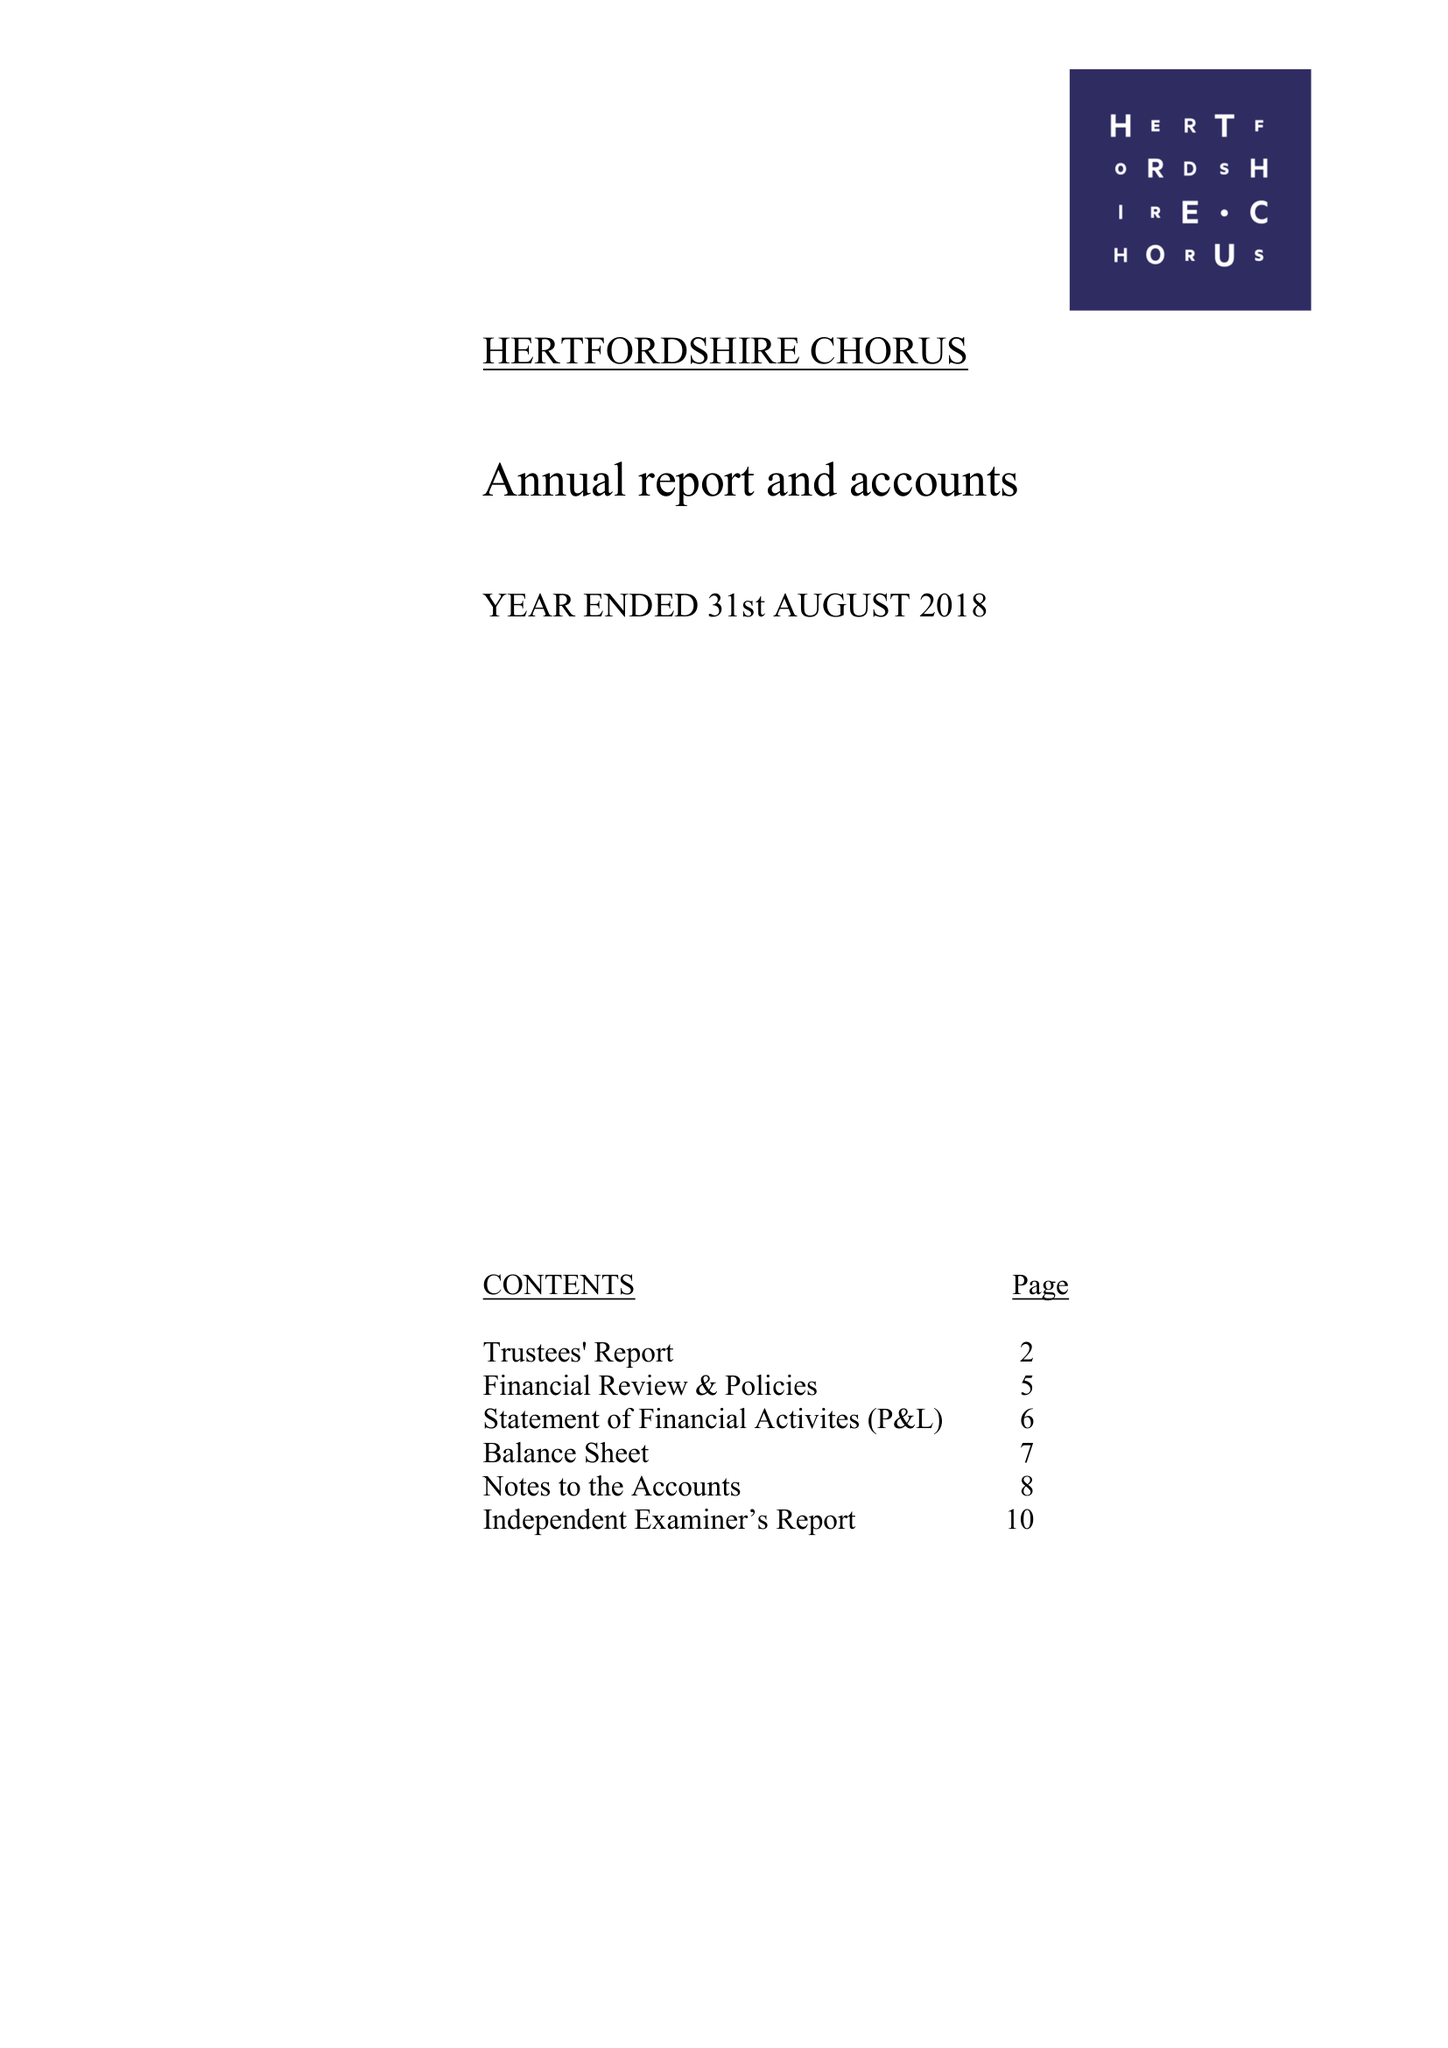What is the value for the spending_annually_in_british_pounds?
Answer the question using a single word or phrase. 105786.00 